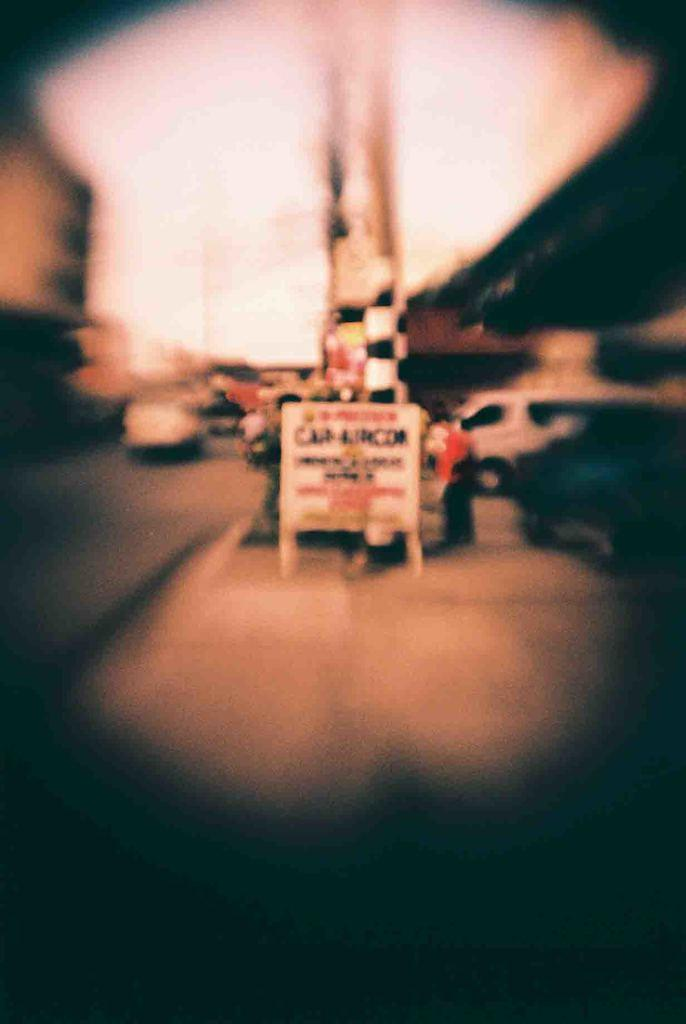What can be seen on the road in the image? There are vehicles on the road in the image. What else is present in the image besides the vehicles? There is a banner in the image, and people are standing behind the banner. Can you describe the quality of the image? The image is blurry. What type of news is being reported on the drain in the image? There is no drain present in the image, nor is there any news being reported. 